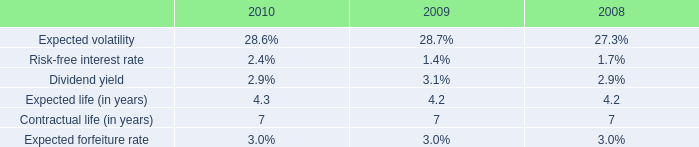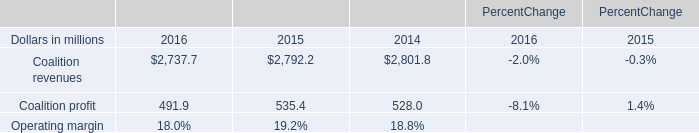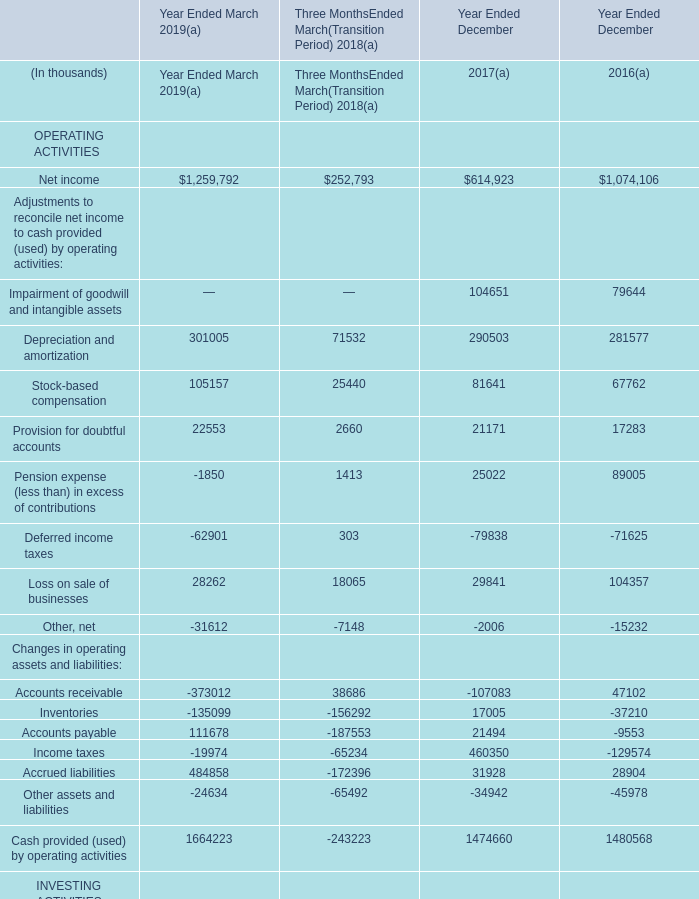What is the difference between the greatest Balances per Consolidated Balance Sheets in 2019 and 2018？ (in thousand) 
Computations: (543011 - 680762)
Answer: -137751.0. 